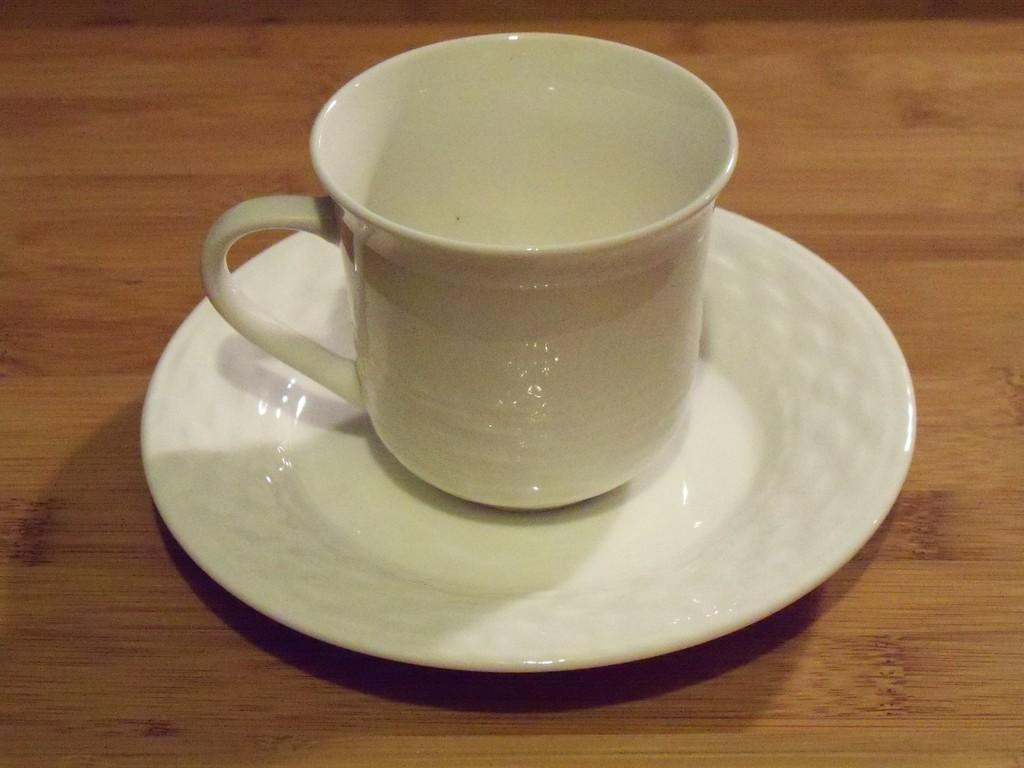What is the main object in the image? There is an empty cup in the image. What color is the cup? The cup is white in color. Is there anything else visible with the cup? The cup is placed on a saucer. What direction does the crook face in the image? There is no crook present in the image. What is the memory associated with the empty cup in the image? The image does not provide any information about a memory associated with the empty cup. 